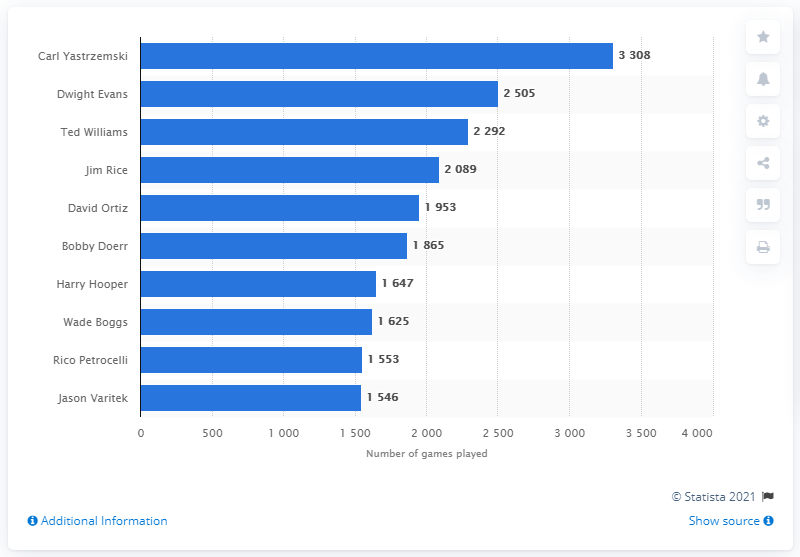Point out several critical features in this image. The individual who played the most games in the history of the Red Sox franchise is Carl Yastrzemski. 